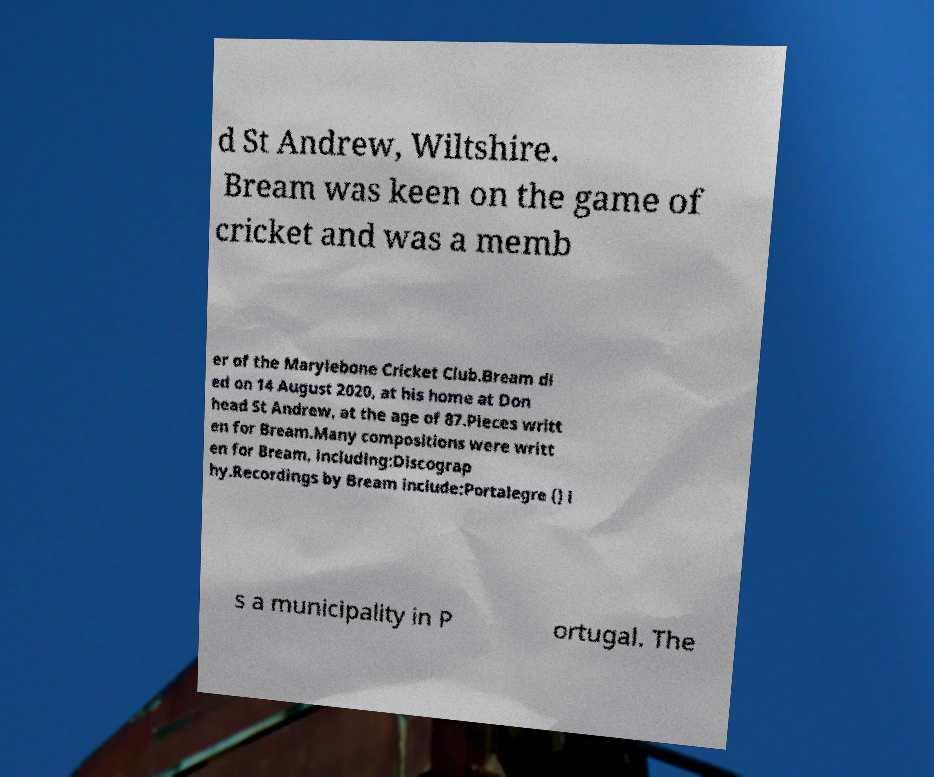Could you extract and type out the text from this image? d St Andrew, Wiltshire. Bream was keen on the game of cricket and was a memb er of the Marylebone Cricket Club.Bream di ed on 14 August 2020, at his home at Don head St Andrew, at the age of 87.Pieces writt en for Bream.Many compositions were writt en for Bream, including:Discograp hy.Recordings by Bream include:Portalegre () i s a municipality in P ortugal. The 